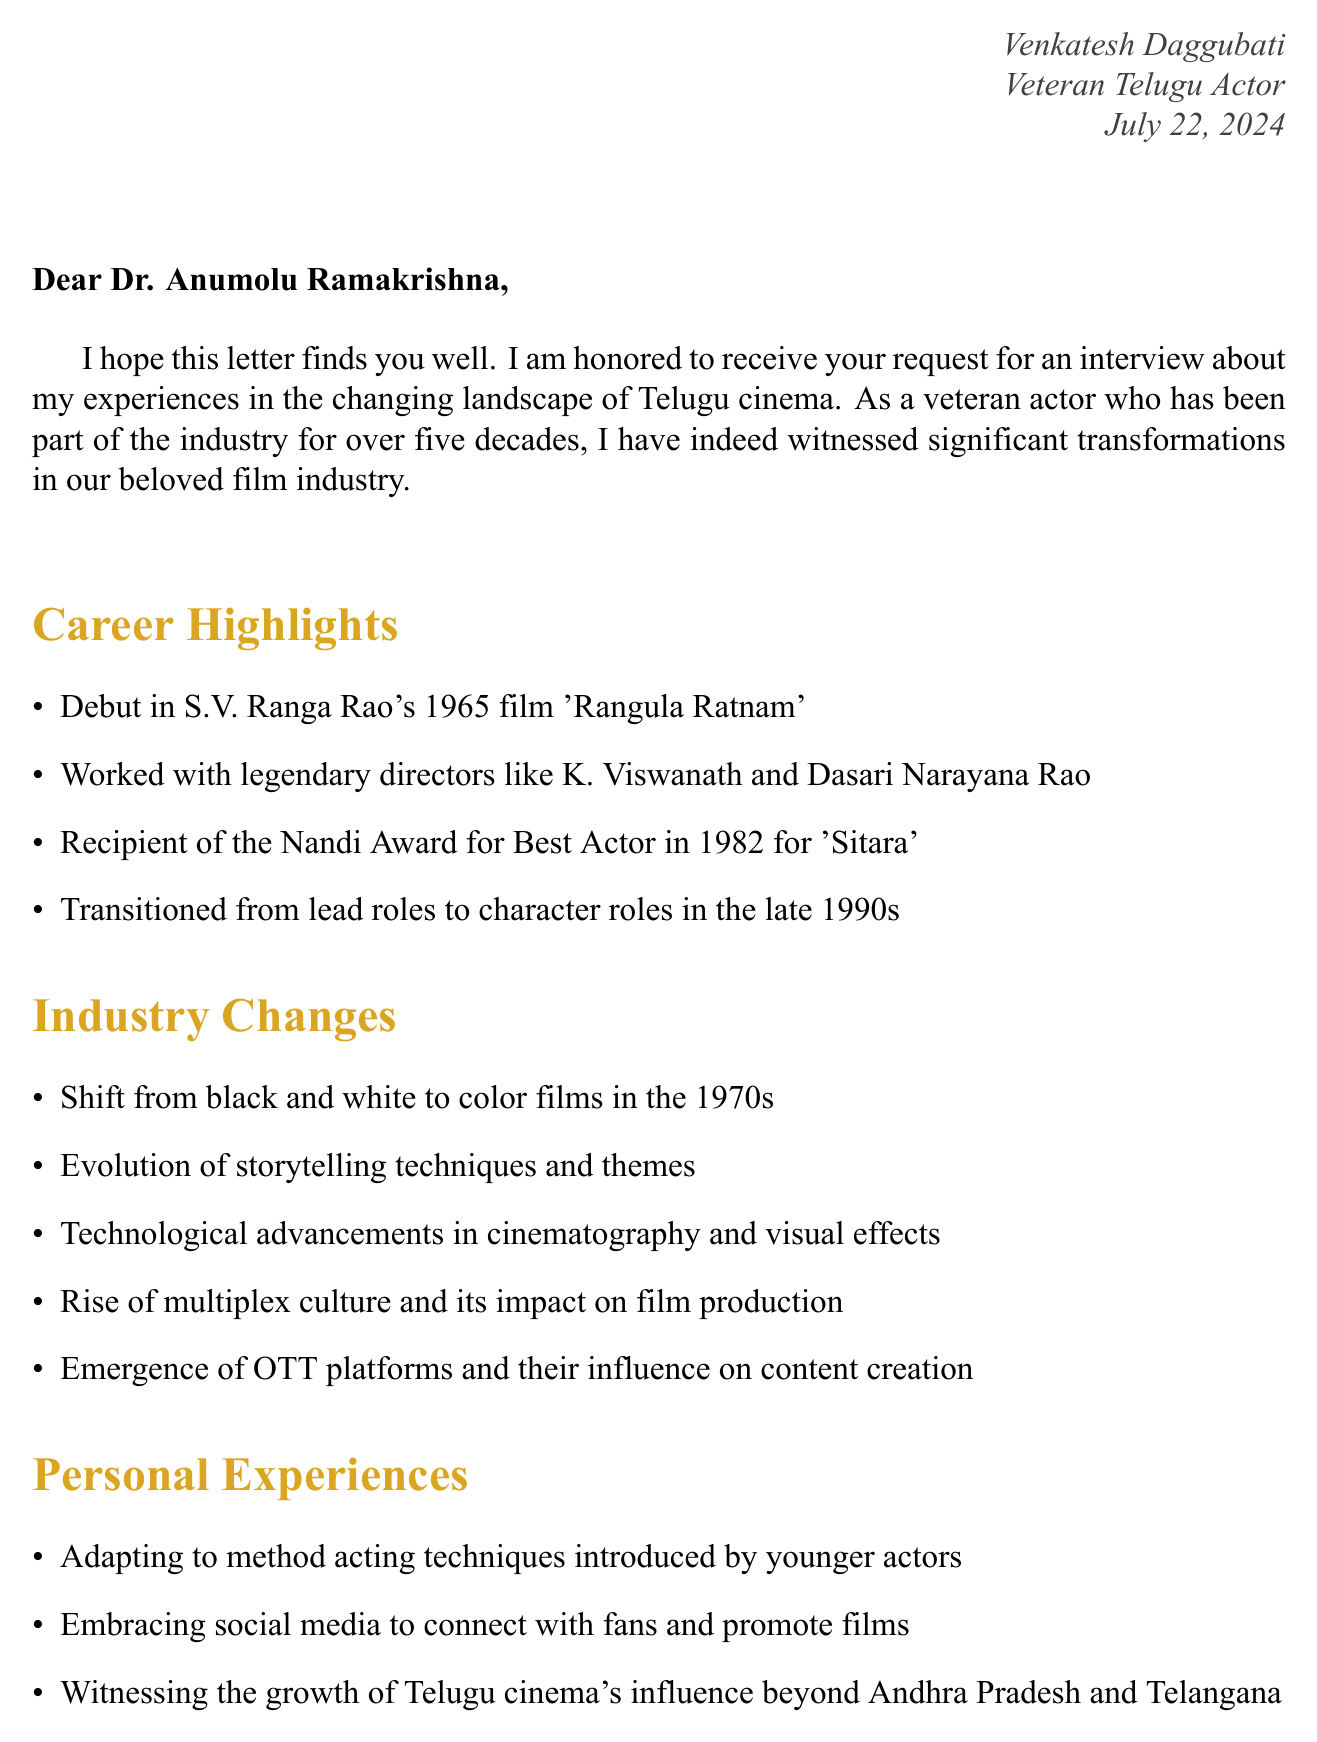What is the sender's name? The sender is Venkatesh Daggubati, as mentioned in the signature.
Answer: Venkatesh Daggubati What film marked the sender's debut? The debut film is 'Rangula Ratnam' from 1965.
Answer: 'Rangula Ratnam' Which award did the sender receive in 1982? The sender received the Nandi Award for Best Actor in 1982.
Answer: Nandi Award for Best Actor What are the proposed dates for the interview? The document lists three proposed dates for the interview: 15th August, 22nd August, and 5th September.
Answer: 15th August, 22nd August, 5th September What location is preferred for the interview? The preferred location for the interview is Film Nagar, Hyderabad.
Answer: Film Nagar, Hyderabad What significant film's impact is mentioned in the additional topics? The film mentioned is 'Baahubali' regarding its global recognition impact.
Answer: Baahubali How long is the proposed duration for the interview? The proposed duration for the interview is 2 hours.
Answer: 2 hours What transformation in film did the sender witness in the 1970s? The sender witnessed a shift from black and white to color films in the 1970s.
Answer: Shift from black and white to color films What aspect of social media does the sender mention experiencing? The sender mentions embracing social media to connect with fans and promote films.
Answer: Embracing social media 